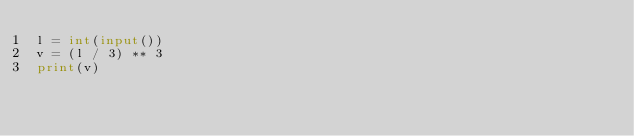Convert code to text. <code><loc_0><loc_0><loc_500><loc_500><_Python_>l = int(input())
v = (l / 3) ** 3
print(v)</code> 